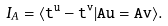<formula> <loc_0><loc_0><loc_500><loc_500>I _ { A } = \langle \tt t ^ { u } - \tt t ^ { v } | A u = A v \rangle .</formula> 